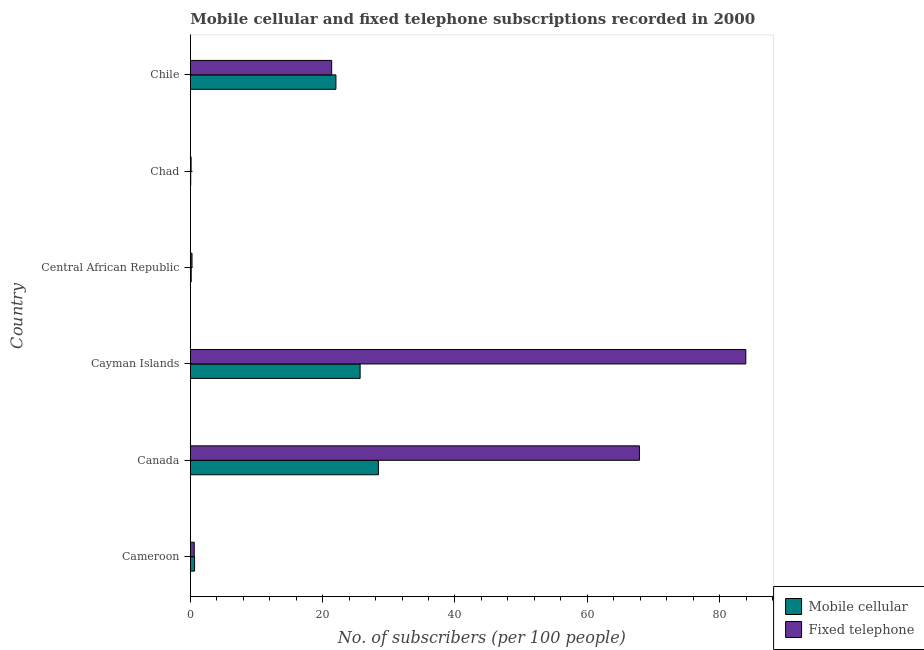How many different coloured bars are there?
Give a very brief answer. 2. How many bars are there on the 1st tick from the bottom?
Offer a terse response. 2. What is the label of the 2nd group of bars from the top?
Provide a succinct answer. Chad. What is the number of fixed telephone subscribers in Cameroon?
Your answer should be compact. 0.6. Across all countries, what is the maximum number of fixed telephone subscribers?
Provide a succinct answer. 83.96. Across all countries, what is the minimum number of mobile cellular subscribers?
Keep it short and to the point. 0.07. In which country was the number of fixed telephone subscribers minimum?
Your answer should be compact. Chad. What is the total number of fixed telephone subscribers in the graph?
Keep it short and to the point. 174.2. What is the difference between the number of mobile cellular subscribers in Central African Republic and that in Chile?
Ensure brevity in your answer.  -21.87. What is the difference between the number of fixed telephone subscribers in Cameroon and the number of mobile cellular subscribers in Chile?
Ensure brevity in your answer.  -21.41. What is the average number of fixed telephone subscribers per country?
Provide a succinct answer. 29.03. What is the difference between the number of fixed telephone subscribers and number of mobile cellular subscribers in Canada?
Your answer should be very brief. 39.46. In how many countries, is the number of mobile cellular subscribers greater than 56 ?
Ensure brevity in your answer.  0. What is the ratio of the number of mobile cellular subscribers in Cayman Islands to that in Central African Republic?
Provide a short and direct response. 188.02. Is the number of mobile cellular subscribers in Cameroon less than that in Canada?
Provide a short and direct response. Yes. What is the difference between the highest and the second highest number of fixed telephone subscribers?
Provide a succinct answer. 16.07. What is the difference between the highest and the lowest number of mobile cellular subscribers?
Make the answer very short. 28.36. In how many countries, is the number of fixed telephone subscribers greater than the average number of fixed telephone subscribers taken over all countries?
Offer a very short reply. 2. Is the sum of the number of fixed telephone subscribers in Canada and Chad greater than the maximum number of mobile cellular subscribers across all countries?
Offer a terse response. Yes. What does the 2nd bar from the top in Canada represents?
Give a very brief answer. Mobile cellular. What does the 1st bar from the bottom in Chile represents?
Provide a short and direct response. Mobile cellular. How many countries are there in the graph?
Ensure brevity in your answer.  6. What is the difference between two consecutive major ticks on the X-axis?
Your answer should be very brief. 20. Does the graph contain grids?
Your response must be concise. No. Where does the legend appear in the graph?
Your answer should be very brief. Bottom right. How are the legend labels stacked?
Your response must be concise. Vertical. What is the title of the graph?
Ensure brevity in your answer.  Mobile cellular and fixed telephone subscriptions recorded in 2000. What is the label or title of the X-axis?
Give a very brief answer. No. of subscribers (per 100 people). What is the label or title of the Y-axis?
Provide a succinct answer. Country. What is the No. of subscribers (per 100 people) in Mobile cellular in Cameroon?
Offer a terse response. 0.65. What is the No. of subscribers (per 100 people) in Fixed telephone in Cameroon?
Provide a succinct answer. 0.6. What is the No. of subscribers (per 100 people) of Mobile cellular in Canada?
Provide a succinct answer. 28.43. What is the No. of subscribers (per 100 people) in Fixed telephone in Canada?
Keep it short and to the point. 67.89. What is the No. of subscribers (per 100 people) in Mobile cellular in Cayman Islands?
Keep it short and to the point. 25.67. What is the No. of subscribers (per 100 people) of Fixed telephone in Cayman Islands?
Provide a succinct answer. 83.96. What is the No. of subscribers (per 100 people) in Mobile cellular in Central African Republic?
Make the answer very short. 0.14. What is the No. of subscribers (per 100 people) of Fixed telephone in Central African Republic?
Your response must be concise. 0.26. What is the No. of subscribers (per 100 people) in Mobile cellular in Chad?
Keep it short and to the point. 0.07. What is the No. of subscribers (per 100 people) in Fixed telephone in Chad?
Make the answer very short. 0.12. What is the No. of subscribers (per 100 people) in Mobile cellular in Chile?
Give a very brief answer. 22.01. What is the No. of subscribers (per 100 people) of Fixed telephone in Chile?
Keep it short and to the point. 21.37. Across all countries, what is the maximum No. of subscribers (per 100 people) in Mobile cellular?
Your answer should be very brief. 28.43. Across all countries, what is the maximum No. of subscribers (per 100 people) in Fixed telephone?
Your answer should be very brief. 83.96. Across all countries, what is the minimum No. of subscribers (per 100 people) of Mobile cellular?
Your answer should be very brief. 0.07. Across all countries, what is the minimum No. of subscribers (per 100 people) of Fixed telephone?
Your response must be concise. 0.12. What is the total No. of subscribers (per 100 people) of Mobile cellular in the graph?
Your answer should be compact. 76.96. What is the total No. of subscribers (per 100 people) of Fixed telephone in the graph?
Your answer should be very brief. 174.2. What is the difference between the No. of subscribers (per 100 people) in Mobile cellular in Cameroon and that in Canada?
Ensure brevity in your answer.  -27.78. What is the difference between the No. of subscribers (per 100 people) in Fixed telephone in Cameroon and that in Canada?
Your answer should be compact. -67.29. What is the difference between the No. of subscribers (per 100 people) of Mobile cellular in Cameroon and that in Cayman Islands?
Offer a terse response. -25.02. What is the difference between the No. of subscribers (per 100 people) in Fixed telephone in Cameroon and that in Cayman Islands?
Offer a terse response. -83.37. What is the difference between the No. of subscribers (per 100 people) in Mobile cellular in Cameroon and that in Central African Republic?
Give a very brief answer. 0.51. What is the difference between the No. of subscribers (per 100 people) of Fixed telephone in Cameroon and that in Central African Republic?
Offer a terse response. 0.34. What is the difference between the No. of subscribers (per 100 people) of Mobile cellular in Cameroon and that in Chad?
Offer a very short reply. 0.58. What is the difference between the No. of subscribers (per 100 people) in Fixed telephone in Cameroon and that in Chad?
Provide a succinct answer. 0.47. What is the difference between the No. of subscribers (per 100 people) of Mobile cellular in Cameroon and that in Chile?
Offer a very short reply. -21.36. What is the difference between the No. of subscribers (per 100 people) of Fixed telephone in Cameroon and that in Chile?
Your answer should be compact. -20.77. What is the difference between the No. of subscribers (per 100 people) in Mobile cellular in Canada and that in Cayman Islands?
Offer a terse response. 2.76. What is the difference between the No. of subscribers (per 100 people) of Fixed telephone in Canada and that in Cayman Islands?
Ensure brevity in your answer.  -16.07. What is the difference between the No. of subscribers (per 100 people) of Mobile cellular in Canada and that in Central African Republic?
Offer a very short reply. 28.29. What is the difference between the No. of subscribers (per 100 people) of Fixed telephone in Canada and that in Central African Republic?
Provide a succinct answer. 67.63. What is the difference between the No. of subscribers (per 100 people) in Mobile cellular in Canada and that in Chad?
Your answer should be compact. 28.36. What is the difference between the No. of subscribers (per 100 people) of Fixed telephone in Canada and that in Chad?
Offer a terse response. 67.76. What is the difference between the No. of subscribers (per 100 people) of Mobile cellular in Canada and that in Chile?
Ensure brevity in your answer.  6.42. What is the difference between the No. of subscribers (per 100 people) in Fixed telephone in Canada and that in Chile?
Offer a very short reply. 46.52. What is the difference between the No. of subscribers (per 100 people) of Mobile cellular in Cayman Islands and that in Central African Republic?
Provide a succinct answer. 25.53. What is the difference between the No. of subscribers (per 100 people) of Fixed telephone in Cayman Islands and that in Central African Republic?
Ensure brevity in your answer.  83.7. What is the difference between the No. of subscribers (per 100 people) of Mobile cellular in Cayman Islands and that in Chad?
Your answer should be compact. 25.6. What is the difference between the No. of subscribers (per 100 people) in Fixed telephone in Cayman Islands and that in Chad?
Your response must be concise. 83.84. What is the difference between the No. of subscribers (per 100 people) of Mobile cellular in Cayman Islands and that in Chile?
Your response must be concise. 3.66. What is the difference between the No. of subscribers (per 100 people) in Fixed telephone in Cayman Islands and that in Chile?
Your response must be concise. 62.59. What is the difference between the No. of subscribers (per 100 people) in Mobile cellular in Central African Republic and that in Chad?
Make the answer very short. 0.07. What is the difference between the No. of subscribers (per 100 people) in Fixed telephone in Central African Republic and that in Chad?
Offer a very short reply. 0.14. What is the difference between the No. of subscribers (per 100 people) of Mobile cellular in Central African Republic and that in Chile?
Offer a very short reply. -21.87. What is the difference between the No. of subscribers (per 100 people) in Fixed telephone in Central African Republic and that in Chile?
Give a very brief answer. -21.11. What is the difference between the No. of subscribers (per 100 people) of Mobile cellular in Chad and that in Chile?
Offer a terse response. -21.94. What is the difference between the No. of subscribers (per 100 people) in Fixed telephone in Chad and that in Chile?
Ensure brevity in your answer.  -21.25. What is the difference between the No. of subscribers (per 100 people) of Mobile cellular in Cameroon and the No. of subscribers (per 100 people) of Fixed telephone in Canada?
Ensure brevity in your answer.  -67.24. What is the difference between the No. of subscribers (per 100 people) in Mobile cellular in Cameroon and the No. of subscribers (per 100 people) in Fixed telephone in Cayman Islands?
Offer a terse response. -83.31. What is the difference between the No. of subscribers (per 100 people) in Mobile cellular in Cameroon and the No. of subscribers (per 100 people) in Fixed telephone in Central African Republic?
Your response must be concise. 0.39. What is the difference between the No. of subscribers (per 100 people) in Mobile cellular in Cameroon and the No. of subscribers (per 100 people) in Fixed telephone in Chad?
Your response must be concise. 0.52. What is the difference between the No. of subscribers (per 100 people) of Mobile cellular in Cameroon and the No. of subscribers (per 100 people) of Fixed telephone in Chile?
Provide a short and direct response. -20.72. What is the difference between the No. of subscribers (per 100 people) in Mobile cellular in Canada and the No. of subscribers (per 100 people) in Fixed telephone in Cayman Islands?
Give a very brief answer. -55.53. What is the difference between the No. of subscribers (per 100 people) of Mobile cellular in Canada and the No. of subscribers (per 100 people) of Fixed telephone in Central African Republic?
Provide a succinct answer. 28.17. What is the difference between the No. of subscribers (per 100 people) of Mobile cellular in Canada and the No. of subscribers (per 100 people) of Fixed telephone in Chad?
Give a very brief answer. 28.31. What is the difference between the No. of subscribers (per 100 people) of Mobile cellular in Canada and the No. of subscribers (per 100 people) of Fixed telephone in Chile?
Ensure brevity in your answer.  7.06. What is the difference between the No. of subscribers (per 100 people) of Mobile cellular in Cayman Islands and the No. of subscribers (per 100 people) of Fixed telephone in Central African Republic?
Offer a very short reply. 25.41. What is the difference between the No. of subscribers (per 100 people) in Mobile cellular in Cayman Islands and the No. of subscribers (per 100 people) in Fixed telephone in Chad?
Your answer should be very brief. 25.55. What is the difference between the No. of subscribers (per 100 people) of Mobile cellular in Cayman Islands and the No. of subscribers (per 100 people) of Fixed telephone in Chile?
Keep it short and to the point. 4.3. What is the difference between the No. of subscribers (per 100 people) in Mobile cellular in Central African Republic and the No. of subscribers (per 100 people) in Fixed telephone in Chad?
Make the answer very short. 0.01. What is the difference between the No. of subscribers (per 100 people) in Mobile cellular in Central African Republic and the No. of subscribers (per 100 people) in Fixed telephone in Chile?
Your response must be concise. -21.23. What is the difference between the No. of subscribers (per 100 people) in Mobile cellular in Chad and the No. of subscribers (per 100 people) in Fixed telephone in Chile?
Your answer should be very brief. -21.3. What is the average No. of subscribers (per 100 people) of Mobile cellular per country?
Ensure brevity in your answer.  12.83. What is the average No. of subscribers (per 100 people) of Fixed telephone per country?
Offer a very short reply. 29.03. What is the difference between the No. of subscribers (per 100 people) in Mobile cellular and No. of subscribers (per 100 people) in Fixed telephone in Cameroon?
Offer a very short reply. 0.05. What is the difference between the No. of subscribers (per 100 people) in Mobile cellular and No. of subscribers (per 100 people) in Fixed telephone in Canada?
Offer a very short reply. -39.46. What is the difference between the No. of subscribers (per 100 people) in Mobile cellular and No. of subscribers (per 100 people) in Fixed telephone in Cayman Islands?
Give a very brief answer. -58.29. What is the difference between the No. of subscribers (per 100 people) of Mobile cellular and No. of subscribers (per 100 people) of Fixed telephone in Central African Republic?
Ensure brevity in your answer.  -0.12. What is the difference between the No. of subscribers (per 100 people) of Mobile cellular and No. of subscribers (per 100 people) of Fixed telephone in Chad?
Give a very brief answer. -0.06. What is the difference between the No. of subscribers (per 100 people) in Mobile cellular and No. of subscribers (per 100 people) in Fixed telephone in Chile?
Give a very brief answer. 0.64. What is the ratio of the No. of subscribers (per 100 people) in Mobile cellular in Cameroon to that in Canada?
Your answer should be very brief. 0.02. What is the ratio of the No. of subscribers (per 100 people) in Fixed telephone in Cameroon to that in Canada?
Make the answer very short. 0.01. What is the ratio of the No. of subscribers (per 100 people) in Mobile cellular in Cameroon to that in Cayman Islands?
Keep it short and to the point. 0.03. What is the ratio of the No. of subscribers (per 100 people) of Fixed telephone in Cameroon to that in Cayman Islands?
Your answer should be compact. 0.01. What is the ratio of the No. of subscribers (per 100 people) in Mobile cellular in Cameroon to that in Central African Republic?
Ensure brevity in your answer.  4.75. What is the ratio of the No. of subscribers (per 100 people) in Fixed telephone in Cameroon to that in Central African Republic?
Offer a terse response. 2.29. What is the ratio of the No. of subscribers (per 100 people) in Mobile cellular in Cameroon to that in Chad?
Your answer should be compact. 9.79. What is the ratio of the No. of subscribers (per 100 people) of Fixed telephone in Cameroon to that in Chad?
Ensure brevity in your answer.  4.83. What is the ratio of the No. of subscribers (per 100 people) of Mobile cellular in Cameroon to that in Chile?
Provide a succinct answer. 0.03. What is the ratio of the No. of subscribers (per 100 people) of Fixed telephone in Cameroon to that in Chile?
Your answer should be very brief. 0.03. What is the ratio of the No. of subscribers (per 100 people) in Mobile cellular in Canada to that in Cayman Islands?
Make the answer very short. 1.11. What is the ratio of the No. of subscribers (per 100 people) of Fixed telephone in Canada to that in Cayman Islands?
Make the answer very short. 0.81. What is the ratio of the No. of subscribers (per 100 people) of Mobile cellular in Canada to that in Central African Republic?
Offer a terse response. 208.24. What is the ratio of the No. of subscribers (per 100 people) of Fixed telephone in Canada to that in Central African Republic?
Provide a short and direct response. 260.88. What is the ratio of the No. of subscribers (per 100 people) of Mobile cellular in Canada to that in Chad?
Your answer should be very brief. 429.08. What is the ratio of the No. of subscribers (per 100 people) of Fixed telephone in Canada to that in Chad?
Keep it short and to the point. 549.22. What is the ratio of the No. of subscribers (per 100 people) of Mobile cellular in Canada to that in Chile?
Offer a very short reply. 1.29. What is the ratio of the No. of subscribers (per 100 people) of Fixed telephone in Canada to that in Chile?
Offer a very short reply. 3.18. What is the ratio of the No. of subscribers (per 100 people) in Mobile cellular in Cayman Islands to that in Central African Republic?
Ensure brevity in your answer.  188.02. What is the ratio of the No. of subscribers (per 100 people) in Fixed telephone in Cayman Islands to that in Central African Republic?
Ensure brevity in your answer.  322.65. What is the ratio of the No. of subscribers (per 100 people) in Mobile cellular in Cayman Islands to that in Chad?
Keep it short and to the point. 387.42. What is the ratio of the No. of subscribers (per 100 people) in Fixed telephone in Cayman Islands to that in Chad?
Your response must be concise. 679.26. What is the ratio of the No. of subscribers (per 100 people) in Mobile cellular in Cayman Islands to that in Chile?
Make the answer very short. 1.17. What is the ratio of the No. of subscribers (per 100 people) in Fixed telephone in Cayman Islands to that in Chile?
Your answer should be compact. 3.93. What is the ratio of the No. of subscribers (per 100 people) in Mobile cellular in Central African Republic to that in Chad?
Provide a short and direct response. 2.06. What is the ratio of the No. of subscribers (per 100 people) of Fixed telephone in Central African Republic to that in Chad?
Your answer should be compact. 2.11. What is the ratio of the No. of subscribers (per 100 people) in Mobile cellular in Central African Republic to that in Chile?
Ensure brevity in your answer.  0.01. What is the ratio of the No. of subscribers (per 100 people) of Fixed telephone in Central African Republic to that in Chile?
Offer a very short reply. 0.01. What is the ratio of the No. of subscribers (per 100 people) of Mobile cellular in Chad to that in Chile?
Make the answer very short. 0. What is the ratio of the No. of subscribers (per 100 people) in Fixed telephone in Chad to that in Chile?
Offer a very short reply. 0.01. What is the difference between the highest and the second highest No. of subscribers (per 100 people) in Mobile cellular?
Give a very brief answer. 2.76. What is the difference between the highest and the second highest No. of subscribers (per 100 people) of Fixed telephone?
Make the answer very short. 16.07. What is the difference between the highest and the lowest No. of subscribers (per 100 people) of Mobile cellular?
Offer a very short reply. 28.36. What is the difference between the highest and the lowest No. of subscribers (per 100 people) of Fixed telephone?
Make the answer very short. 83.84. 